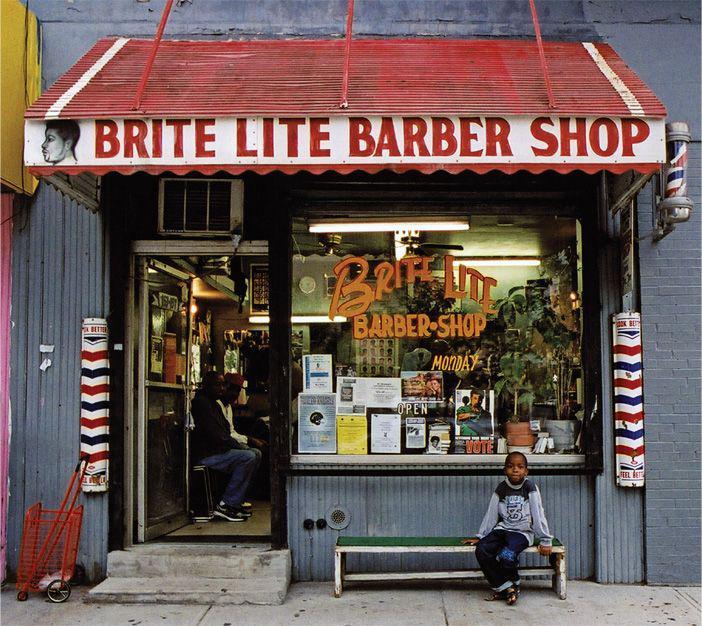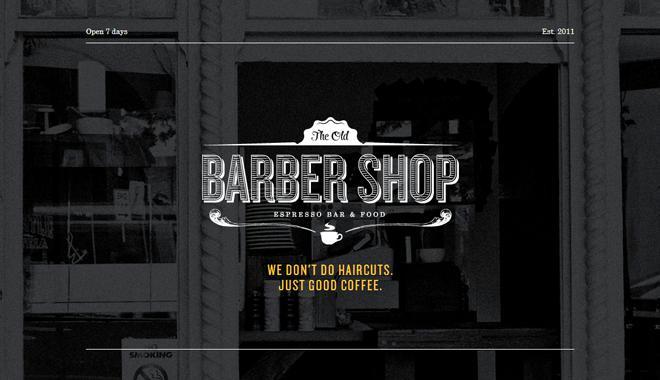The first image is the image on the left, the second image is the image on the right. Examine the images to the left and right. Is the description "A barber shop has a red brick exterior with a row of black-rimmed windows parallel to the sidewalk." accurate? Answer yes or no. No. 